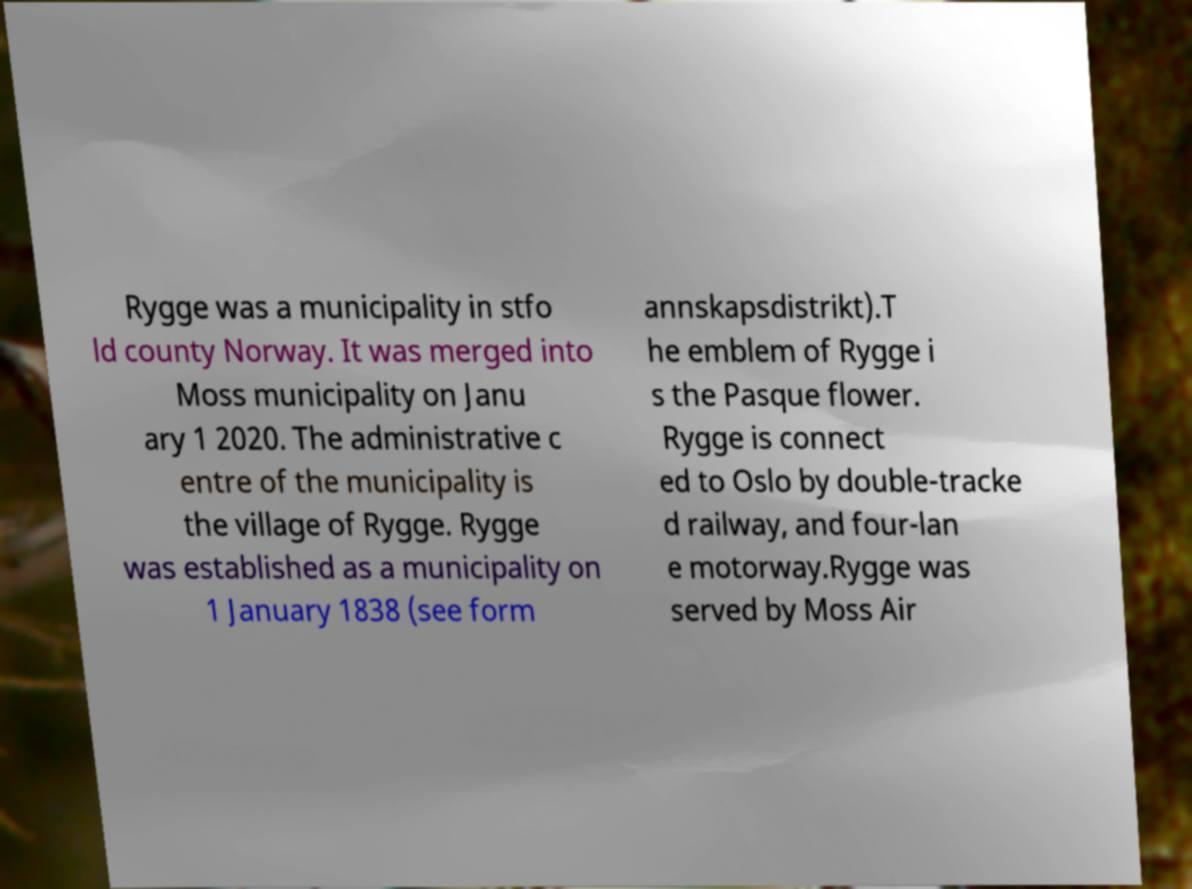Can you read and provide the text displayed in the image?This photo seems to have some interesting text. Can you extract and type it out for me? Rygge was a municipality in stfo ld county Norway. It was merged into Moss municipality on Janu ary 1 2020. The administrative c entre of the municipality is the village of Rygge. Rygge was established as a municipality on 1 January 1838 (see form annskapsdistrikt).T he emblem of Rygge i s the Pasque flower. Rygge is connect ed to Oslo by double-tracke d railway, and four-lan e motorway.Rygge was served by Moss Air 